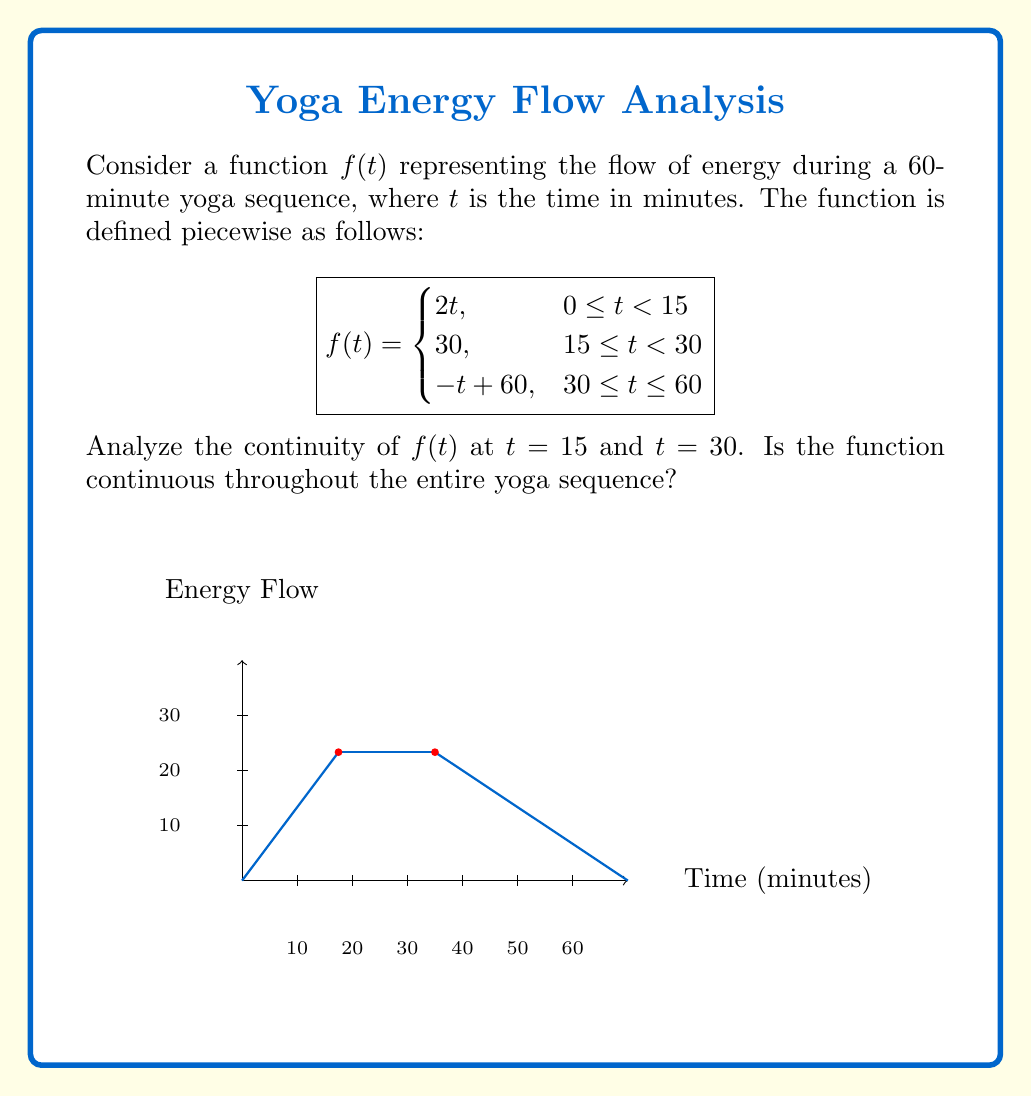Solve this math problem. To analyze the continuity of $f(t)$, we need to check if the function is continuous at the points where the piecewise definition changes, namely at $t = 15$ and $t = 30$.

1. Continuity at $t = 15$:
   - Left-hand limit: $\lim_{t \to 15^-} f(t) = \lim_{t \to 15^-} 2t = 30$
   - Right-hand limit: $\lim_{t \to 15^+} f(t) = 30$
   - Function value: $f(15) = 30$
   
   Since the left-hand limit, right-hand limit, and function value are all equal, $f(t)$ is continuous at $t = 15$.

2. Continuity at $t = 30$:
   - Left-hand limit: $\lim_{t \to 30^-} f(t) = 30$
   - Right-hand limit: $\lim_{t \to 30^+} f(t) = \lim_{t \to 30^+} (-t + 60) = 30$
   - Function value: $f(30) = 30$
   
   Since the left-hand limit, right-hand limit, and function value are all equal, $f(t)$ is continuous at $t = 30$.

3. Continuity on the intervals:
   - On $[0, 15)$, $f(t) = 2t$ is continuous as it's a linear function.
   - On $[15, 30)$, $f(t) = 30$ is continuous as it's a constant function.
   - On $[30, 60]$, $f(t) = -t + 60$ is continuous as it's a linear function.

Since $f(t)$ is continuous at the transition points ($t = 15$ and $t = 30$) and on all intervals of its domain, we can conclude that $f(t)$ is continuous throughout the entire yoga sequence, i.e., on the interval $[0, 60]$.
Answer: $f(t)$ is continuous on $[0, 60]$. 